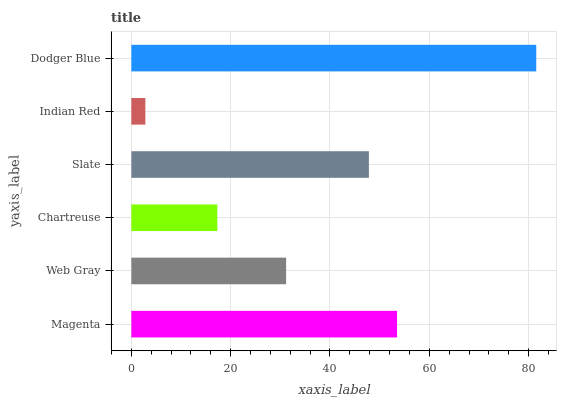Is Indian Red the minimum?
Answer yes or no. Yes. Is Dodger Blue the maximum?
Answer yes or no. Yes. Is Web Gray the minimum?
Answer yes or no. No. Is Web Gray the maximum?
Answer yes or no. No. Is Magenta greater than Web Gray?
Answer yes or no. Yes. Is Web Gray less than Magenta?
Answer yes or no. Yes. Is Web Gray greater than Magenta?
Answer yes or no. No. Is Magenta less than Web Gray?
Answer yes or no. No. Is Slate the high median?
Answer yes or no. Yes. Is Web Gray the low median?
Answer yes or no. Yes. Is Chartreuse the high median?
Answer yes or no. No. Is Chartreuse the low median?
Answer yes or no. No. 